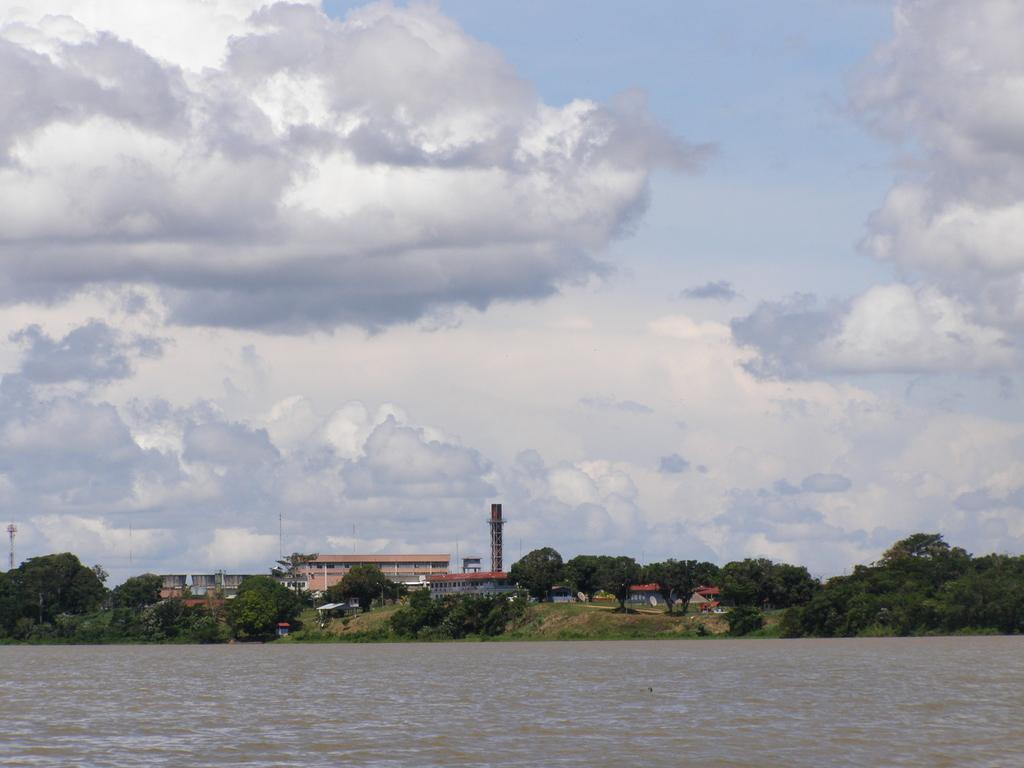What type of natural feature can be seen in the image? There is a river in the image. What other elements are present in the image besides the river? There are trees and buildings in the image. What part of the natural environment is visible in the image? The sky is visible in the image. How much sugar is dissolved in the river in the image? There is no sugar present in the river in the image. 